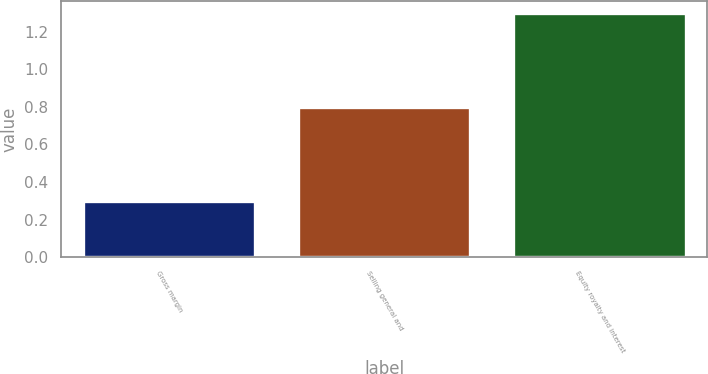Convert chart to OTSL. <chart><loc_0><loc_0><loc_500><loc_500><bar_chart><fcel>Gross margin<fcel>Selling general and<fcel>Equity royalty and interest<nl><fcel>0.3<fcel>0.8<fcel>1.3<nl></chart> 